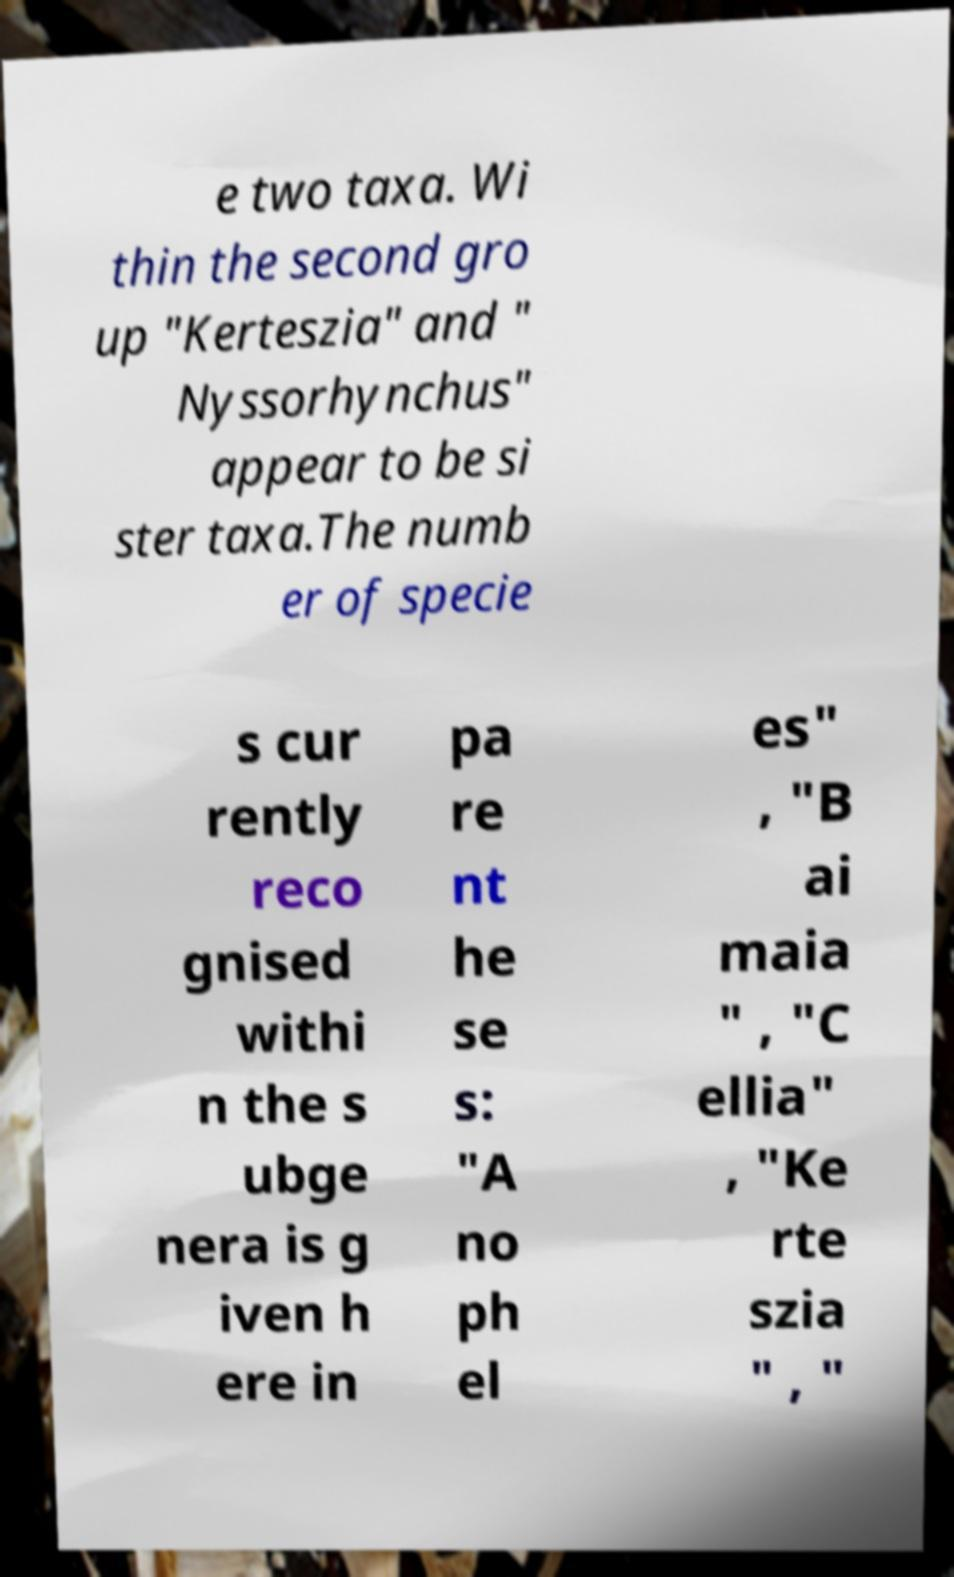Could you extract and type out the text from this image? e two taxa. Wi thin the second gro up "Kerteszia" and " Nyssorhynchus" appear to be si ster taxa.The numb er of specie s cur rently reco gnised withi n the s ubge nera is g iven h ere in pa re nt he se s: "A no ph el es" , "B ai maia " , "C ellia" , "Ke rte szia " , " 